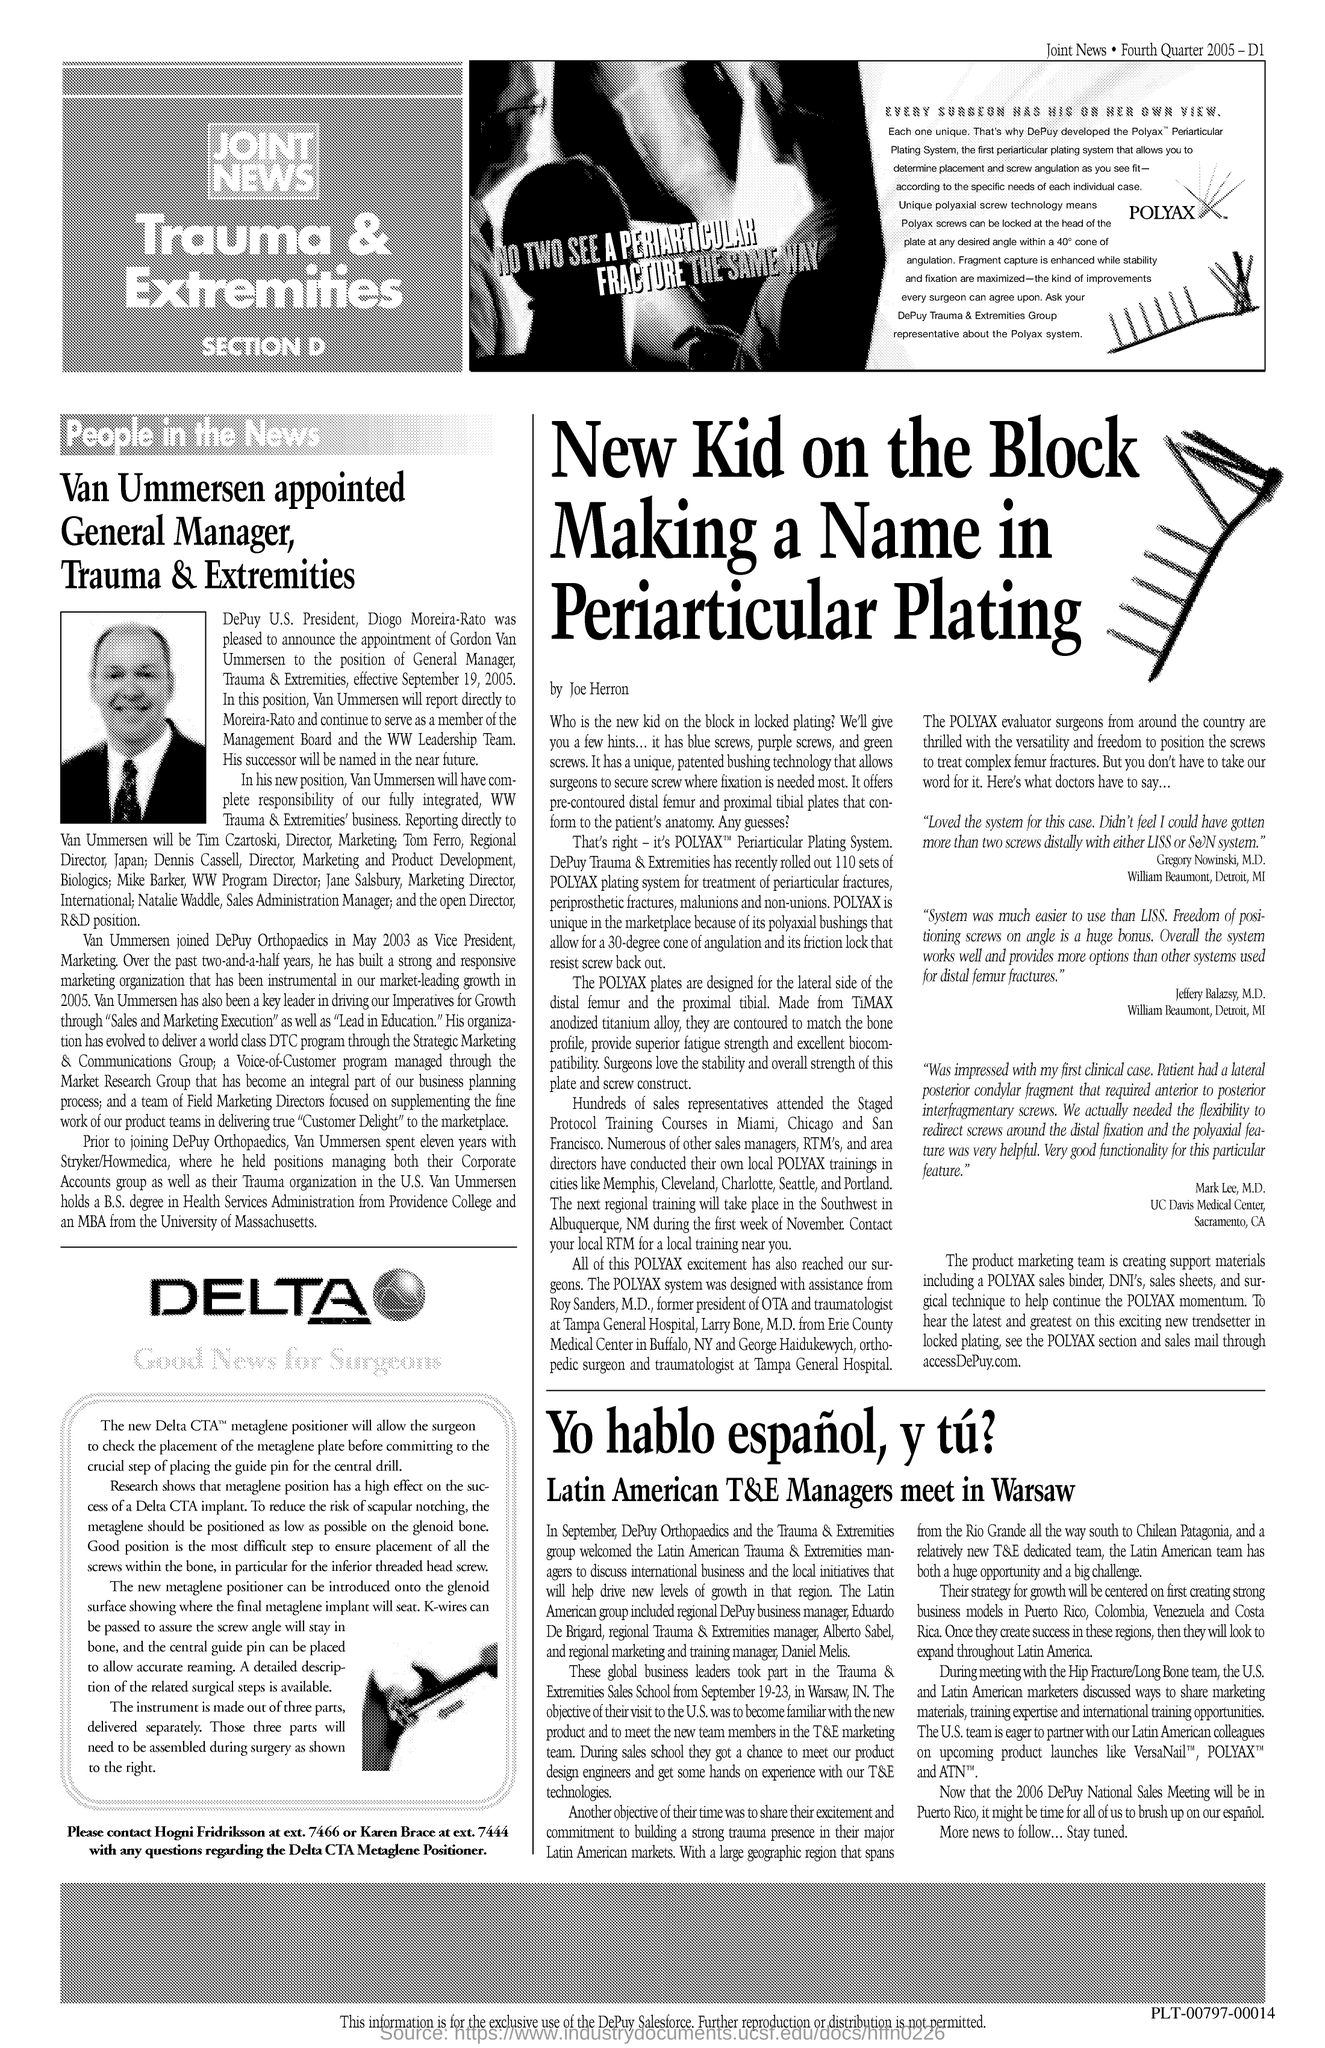Who is the General Manager of Trauma & Extremities?
Ensure brevity in your answer.  Van Ummersen. 